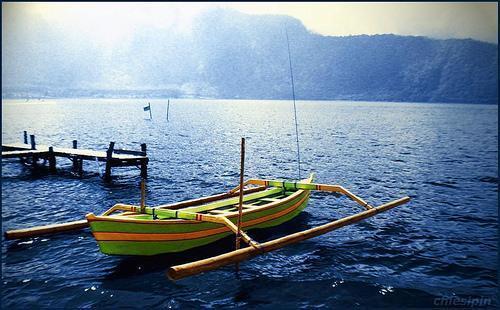How many canoes are in the picture?
Give a very brief answer. 1. 